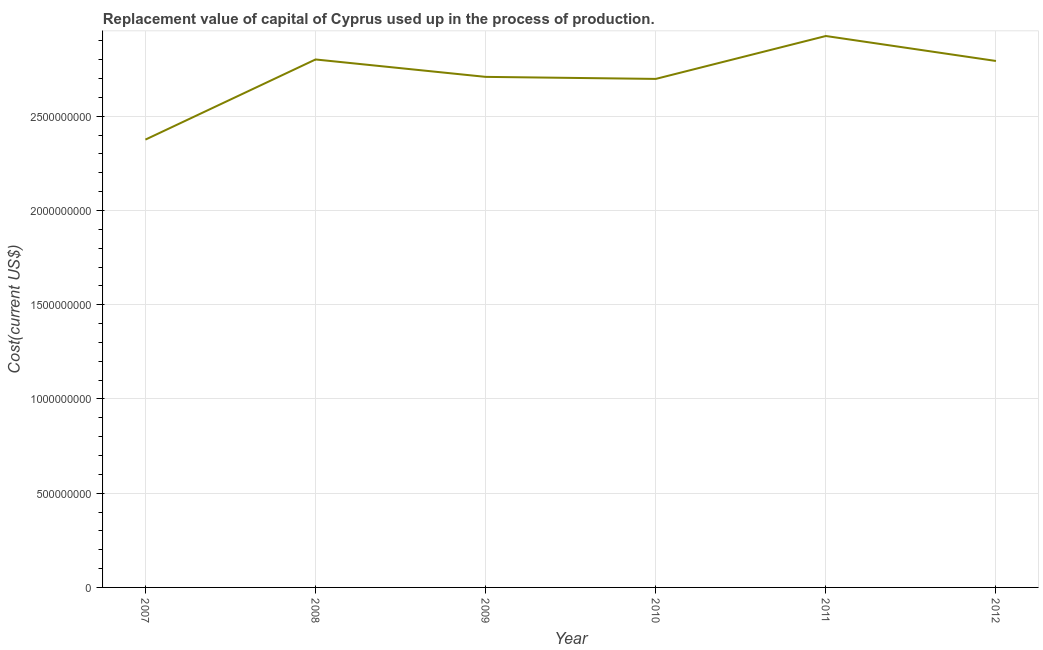What is the consumption of fixed capital in 2007?
Make the answer very short. 2.38e+09. Across all years, what is the maximum consumption of fixed capital?
Ensure brevity in your answer.  2.93e+09. Across all years, what is the minimum consumption of fixed capital?
Offer a very short reply. 2.38e+09. In which year was the consumption of fixed capital minimum?
Provide a short and direct response. 2007. What is the sum of the consumption of fixed capital?
Your answer should be compact. 1.63e+1. What is the difference between the consumption of fixed capital in 2010 and 2012?
Give a very brief answer. -9.52e+07. What is the average consumption of fixed capital per year?
Offer a terse response. 2.72e+09. What is the median consumption of fixed capital?
Your response must be concise. 2.75e+09. What is the ratio of the consumption of fixed capital in 2008 to that in 2012?
Provide a short and direct response. 1. Is the consumption of fixed capital in 2008 less than that in 2009?
Ensure brevity in your answer.  No. What is the difference between the highest and the second highest consumption of fixed capital?
Offer a very short reply. 1.24e+08. What is the difference between the highest and the lowest consumption of fixed capital?
Give a very brief answer. 5.50e+08. In how many years, is the consumption of fixed capital greater than the average consumption of fixed capital taken over all years?
Keep it short and to the point. 3. How many lines are there?
Provide a succinct answer. 1. How many years are there in the graph?
Offer a very short reply. 6. Are the values on the major ticks of Y-axis written in scientific E-notation?
Keep it short and to the point. No. What is the title of the graph?
Provide a short and direct response. Replacement value of capital of Cyprus used up in the process of production. What is the label or title of the X-axis?
Your response must be concise. Year. What is the label or title of the Y-axis?
Provide a succinct answer. Cost(current US$). What is the Cost(current US$) of 2007?
Give a very brief answer. 2.38e+09. What is the Cost(current US$) of 2008?
Your response must be concise. 2.80e+09. What is the Cost(current US$) of 2009?
Your answer should be compact. 2.71e+09. What is the Cost(current US$) of 2010?
Keep it short and to the point. 2.70e+09. What is the Cost(current US$) in 2011?
Offer a very short reply. 2.93e+09. What is the Cost(current US$) of 2012?
Your answer should be compact. 2.79e+09. What is the difference between the Cost(current US$) in 2007 and 2008?
Your answer should be very brief. -4.25e+08. What is the difference between the Cost(current US$) in 2007 and 2009?
Keep it short and to the point. -3.33e+08. What is the difference between the Cost(current US$) in 2007 and 2010?
Your response must be concise. -3.22e+08. What is the difference between the Cost(current US$) in 2007 and 2011?
Keep it short and to the point. -5.50e+08. What is the difference between the Cost(current US$) in 2007 and 2012?
Give a very brief answer. -4.17e+08. What is the difference between the Cost(current US$) in 2008 and 2009?
Give a very brief answer. 9.24e+07. What is the difference between the Cost(current US$) in 2008 and 2010?
Offer a very short reply. 1.03e+08. What is the difference between the Cost(current US$) in 2008 and 2011?
Give a very brief answer. -1.24e+08. What is the difference between the Cost(current US$) in 2008 and 2012?
Keep it short and to the point. 8.00e+06. What is the difference between the Cost(current US$) in 2009 and 2010?
Provide a succinct answer. 1.08e+07. What is the difference between the Cost(current US$) in 2009 and 2011?
Offer a terse response. -2.17e+08. What is the difference between the Cost(current US$) in 2009 and 2012?
Offer a very short reply. -8.44e+07. What is the difference between the Cost(current US$) in 2010 and 2011?
Give a very brief answer. -2.28e+08. What is the difference between the Cost(current US$) in 2010 and 2012?
Make the answer very short. -9.52e+07. What is the difference between the Cost(current US$) in 2011 and 2012?
Make the answer very short. 1.32e+08. What is the ratio of the Cost(current US$) in 2007 to that in 2008?
Your answer should be very brief. 0.85. What is the ratio of the Cost(current US$) in 2007 to that in 2009?
Provide a succinct answer. 0.88. What is the ratio of the Cost(current US$) in 2007 to that in 2010?
Your response must be concise. 0.88. What is the ratio of the Cost(current US$) in 2007 to that in 2011?
Offer a very short reply. 0.81. What is the ratio of the Cost(current US$) in 2007 to that in 2012?
Your answer should be compact. 0.85. What is the ratio of the Cost(current US$) in 2008 to that in 2009?
Give a very brief answer. 1.03. What is the ratio of the Cost(current US$) in 2008 to that in 2010?
Your response must be concise. 1.04. What is the ratio of the Cost(current US$) in 2008 to that in 2012?
Offer a very short reply. 1. What is the ratio of the Cost(current US$) in 2009 to that in 2010?
Offer a very short reply. 1. What is the ratio of the Cost(current US$) in 2009 to that in 2011?
Provide a succinct answer. 0.93. What is the ratio of the Cost(current US$) in 2010 to that in 2011?
Your answer should be very brief. 0.92. What is the ratio of the Cost(current US$) in 2011 to that in 2012?
Offer a terse response. 1.05. 